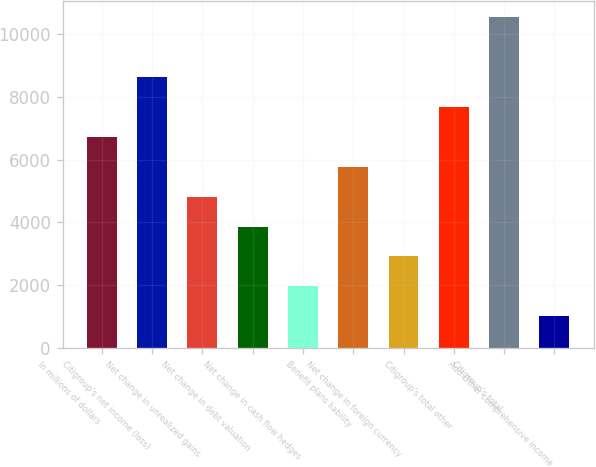<chart> <loc_0><loc_0><loc_500><loc_500><bar_chart><fcel>In millions of dollars<fcel>Citigroup's net income (loss)<fcel>Net change in unrealized gains<fcel>Net change in debt valuation<fcel>Net change in cash flow hedges<fcel>Benefit plans liability<fcel>Net change in foreign currency<fcel>Citigroup's total other<fcel>Citigroup's total<fcel>Add Other comprehensive income<nl><fcel>6730.3<fcel>8636.1<fcel>4824.5<fcel>3871.6<fcel>1965.8<fcel>5777.4<fcel>2918.7<fcel>7683.2<fcel>10541.9<fcel>1012.9<nl></chart> 